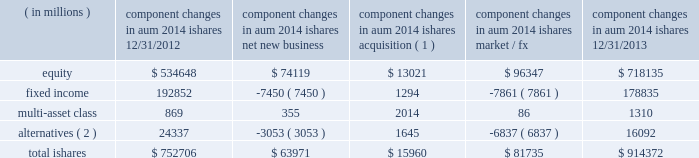The second largest closed-end fund manager and a top- ten manager by aum and 2013 net flows of long-term open-end mutual funds1 .
In 2013 , we were also the leading manager by net flows for long-dated fixed income mutual funds1 .
2022 we have fully integrated our legacy retail and ishares retail distribution teams to create a unified client-facing presence .
As retail clients increasingly use blackrock 2019s capabilities in combination 2014 active , alternative and passive 2014 it is a strategic priority for blackrock to coherently deliver these capabilities through one integrated team .
2022 international retail long-term net inflows of $ 17.5 billion , representing 15% ( 15 % ) organic growth , were positive across major regions and diversified across asset classes .
Equity net inflows of $ 6.4 billion were driven by strong demand for our top-performing european equities franchise as investor risk appetite for the sector improved .
Multi-asset class and fixed income products each generated net inflows of $ 4.8 billion , as investors looked to manage duration and volatility in their portfolios .
In 2013 , we were ranked as the third largest cross border fund provider2 .
In the united kingdom , we ranked among the five largest fund managers2 .
Ishares .
Alternatives ( 2 ) 24337 ( 3053 ) 1645 ( 6837 ) 16092 total ishares $ 752706 $ 63971 $ 15960 $ 81735 $ 914372 ( 1 ) amounts represent $ 16.0 billion of aum acquired in the credit suisse etf acquisition in july 2013 .
( 2 ) amounts include commodity ishares .
Ishares is the leading etf provider in the world , with $ 914.4 billion of aum at december 31 , 2013 , and was the top asset gatherer globally in 20133 with $ 64.0 billion of net inflows for an organic growth rate of 8% ( 8 % ) .
Equity net inflows of $ 74.1 billion were driven by flows into funds with broad developed market exposures , partially offset by outflows from emerging markets products .
Ishares fixed income experienced net outflows of $ 7.5 billion , as the continued low interest rate environment led many liquidity-oriented investors to sell long-duration assets , which made up the majority of the ishares fixed income suite .
In 2013 , we launched several funds to meet demand from clients seeking protection in a rising interest rate environment by offering an expanded product set that includes four new u.s .
Funds , including short-duration versions of our flagship high yield and investment grade credit products , and short maturity and liquidity income funds .
Ishares alternatives had $ 3.1 billion of net outflows predominantly out of commodities .
Ishares represented 23% ( 23 % ) of long-term aum at december 31 , 2013 and 35% ( 35 % ) of long-term base fees for ishares offers the most diverse product set in the industry with 703 etfs at year-end 2013 , and serves the broadest client base , covering more than 25 countries on five continents .
During 2013 , ishares continued its dual commitment to innovation and responsible product structuring by introducing 42 new etfs , acquiring credit suisse 2019s 58 etfs in europe and entering into a critical new strategic alliance with fidelity investments to deliver fidelity 2019s more than 10 million clients increased access to ishares products , tools and support .
Our alliance with fidelity investments and a successful full first year for the core series have deeply expanded our presence and offerings among buy-and-hold investors .
Our broad product range offers investors a precise , transparent and low-cost way to tap market returns and gain access to a full range of asset classes and global markets that have been difficult or expensive for many investors to access until now , as well as the liquidity required to make adjustments to their exposures quickly and cost-efficiently .
2022 u.s .
Ishares aum ended at $ 655.6 billion with $ 41.4 billion of net inflows driven by strong demand for developed markets equities and short-duration fixed income .
During the fourth quarter of 2012 , we debuted the core series in the united states , designed to provide the essential building blocks for buy-and-hold investors to use in constructing the core of their portfolio .
The core series demonstrated solid results in its first full year , raising $ 20.0 billion in net inflows , primarily in u.s .
Equities .
In the united states , ishares maintained its position as the largest etf provider , with 39% ( 39 % ) share of aum3 .
2022 international ishares aum ended at $ 258.8 billion with robust net new business of $ 22.6 billion led by demand for european and japanese equities , as well as a diverse range of fixed income products .
At year-end 2013 , ishares was the largest european etf provider with 48% ( 48 % ) of aum3 .
1 simfund 2 lipper feri 3 blackrock ; bloomberg .
What portion of the total ishares managed by blackrock is composed of fixed income assets as of december 31 , 2013? 
Computations: (178835 / 914372)
Answer: 0.19558. 